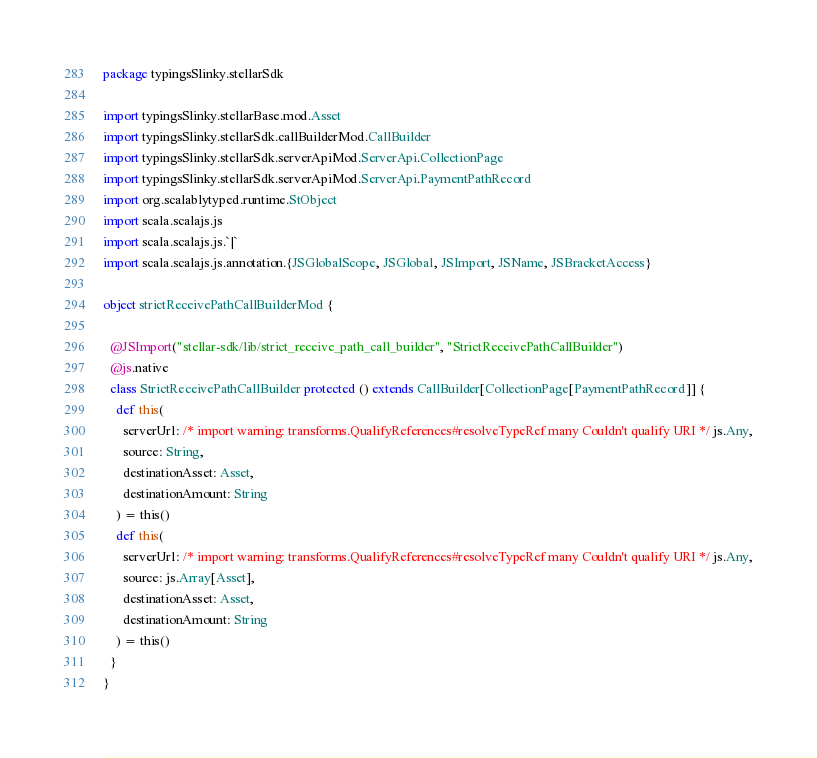Convert code to text. <code><loc_0><loc_0><loc_500><loc_500><_Scala_>package typingsSlinky.stellarSdk

import typingsSlinky.stellarBase.mod.Asset
import typingsSlinky.stellarSdk.callBuilderMod.CallBuilder
import typingsSlinky.stellarSdk.serverApiMod.ServerApi.CollectionPage
import typingsSlinky.stellarSdk.serverApiMod.ServerApi.PaymentPathRecord
import org.scalablytyped.runtime.StObject
import scala.scalajs.js
import scala.scalajs.js.`|`
import scala.scalajs.js.annotation.{JSGlobalScope, JSGlobal, JSImport, JSName, JSBracketAccess}

object strictReceivePathCallBuilderMod {
  
  @JSImport("stellar-sdk/lib/strict_receive_path_call_builder", "StrictReceivePathCallBuilder")
  @js.native
  class StrictReceivePathCallBuilder protected () extends CallBuilder[CollectionPage[PaymentPathRecord]] {
    def this(
      serverUrl: /* import warning: transforms.QualifyReferences#resolveTypeRef many Couldn't qualify URI */ js.Any,
      source: String,
      destinationAsset: Asset,
      destinationAmount: String
    ) = this()
    def this(
      serverUrl: /* import warning: transforms.QualifyReferences#resolveTypeRef many Couldn't qualify URI */ js.Any,
      source: js.Array[Asset],
      destinationAsset: Asset,
      destinationAmount: String
    ) = this()
  }
}
</code> 